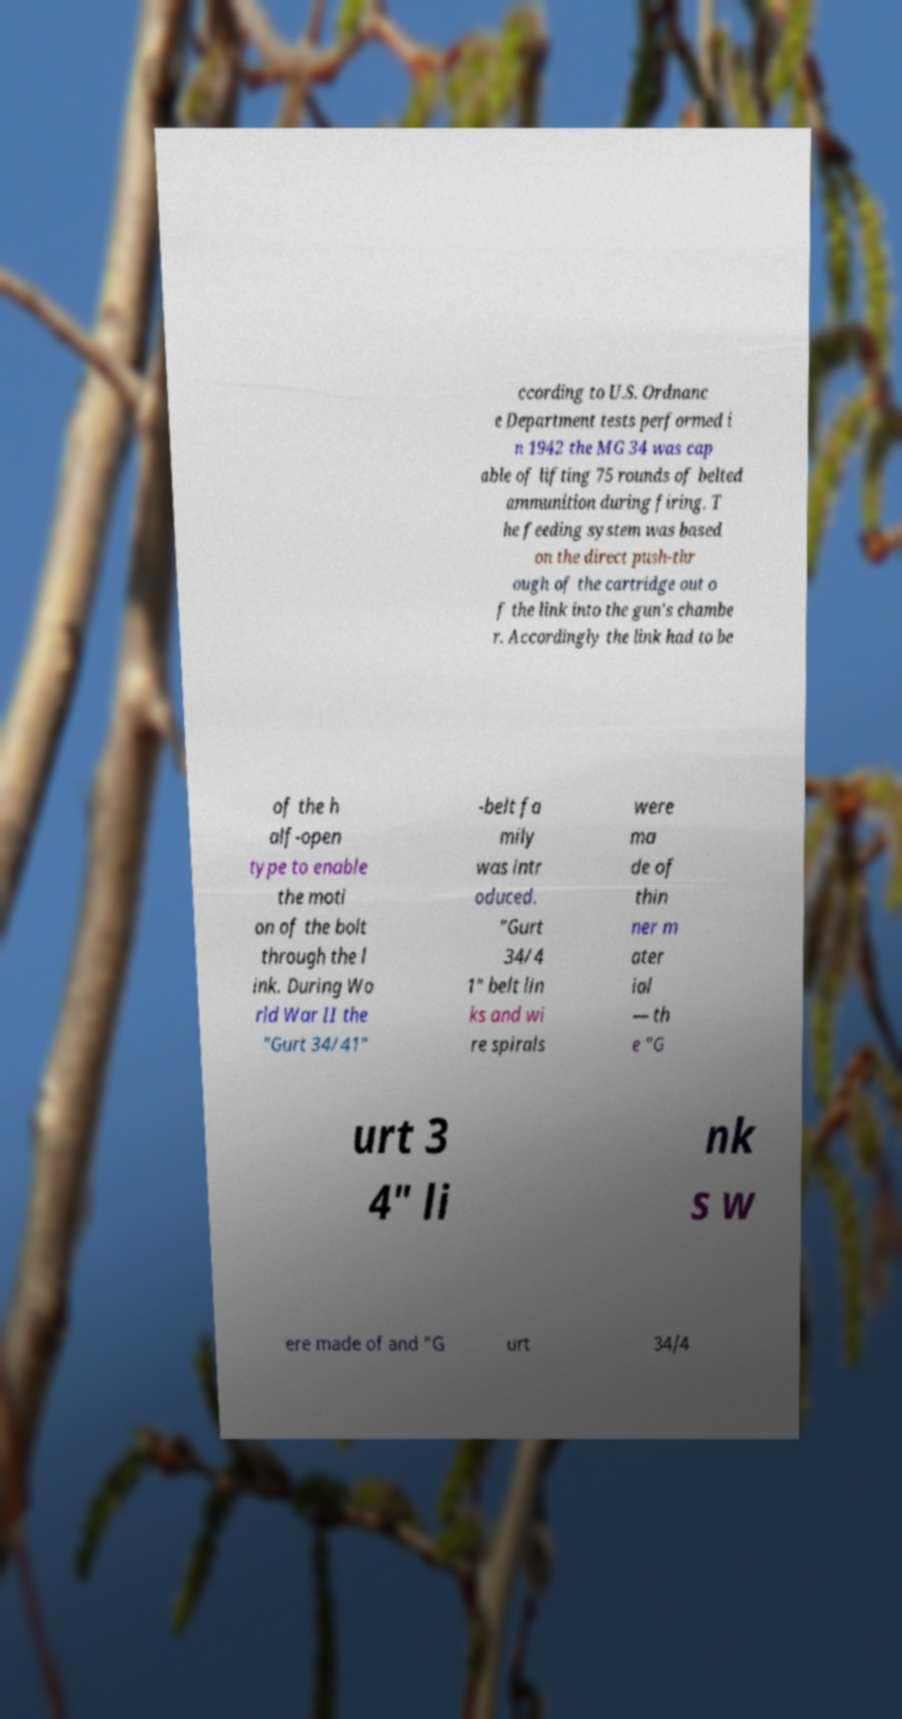There's text embedded in this image that I need extracted. Can you transcribe it verbatim? ccording to U.S. Ordnanc e Department tests performed i n 1942 the MG 34 was cap able of lifting 75 rounds of belted ammunition during firing. T he feeding system was based on the direct push-thr ough of the cartridge out o f the link into the gun's chambe r. Accordingly the link had to be of the h alf-open type to enable the moti on of the bolt through the l ink. During Wo rld War II the "Gurt 34/41" -belt fa mily was intr oduced. "Gurt 34/4 1" belt lin ks and wi re spirals were ma de of thin ner m ater ial — th e "G urt 3 4" li nk s w ere made of and "G urt 34/4 